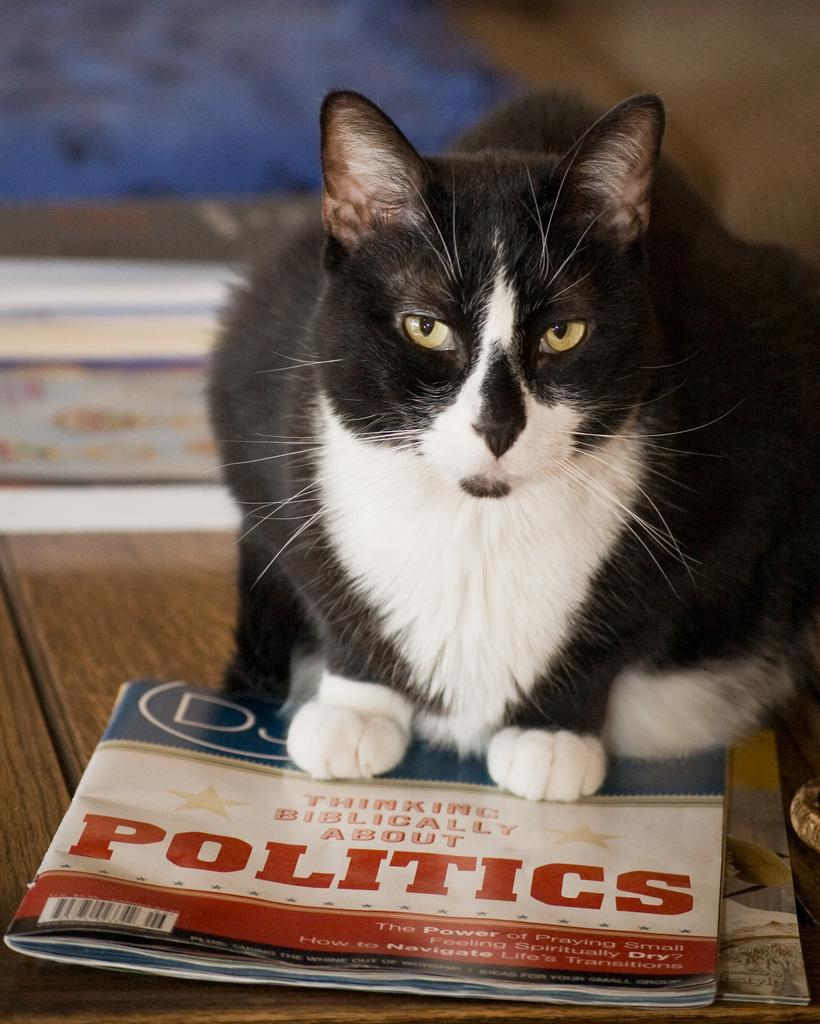Provide a one-sentence caption for the provided image. A black and white cat sitting on a magazine about politics. 